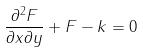<formula> <loc_0><loc_0><loc_500><loc_500>\frac { \partial ^ { 2 } F } { \partial x \partial y } + F - k = 0</formula> 